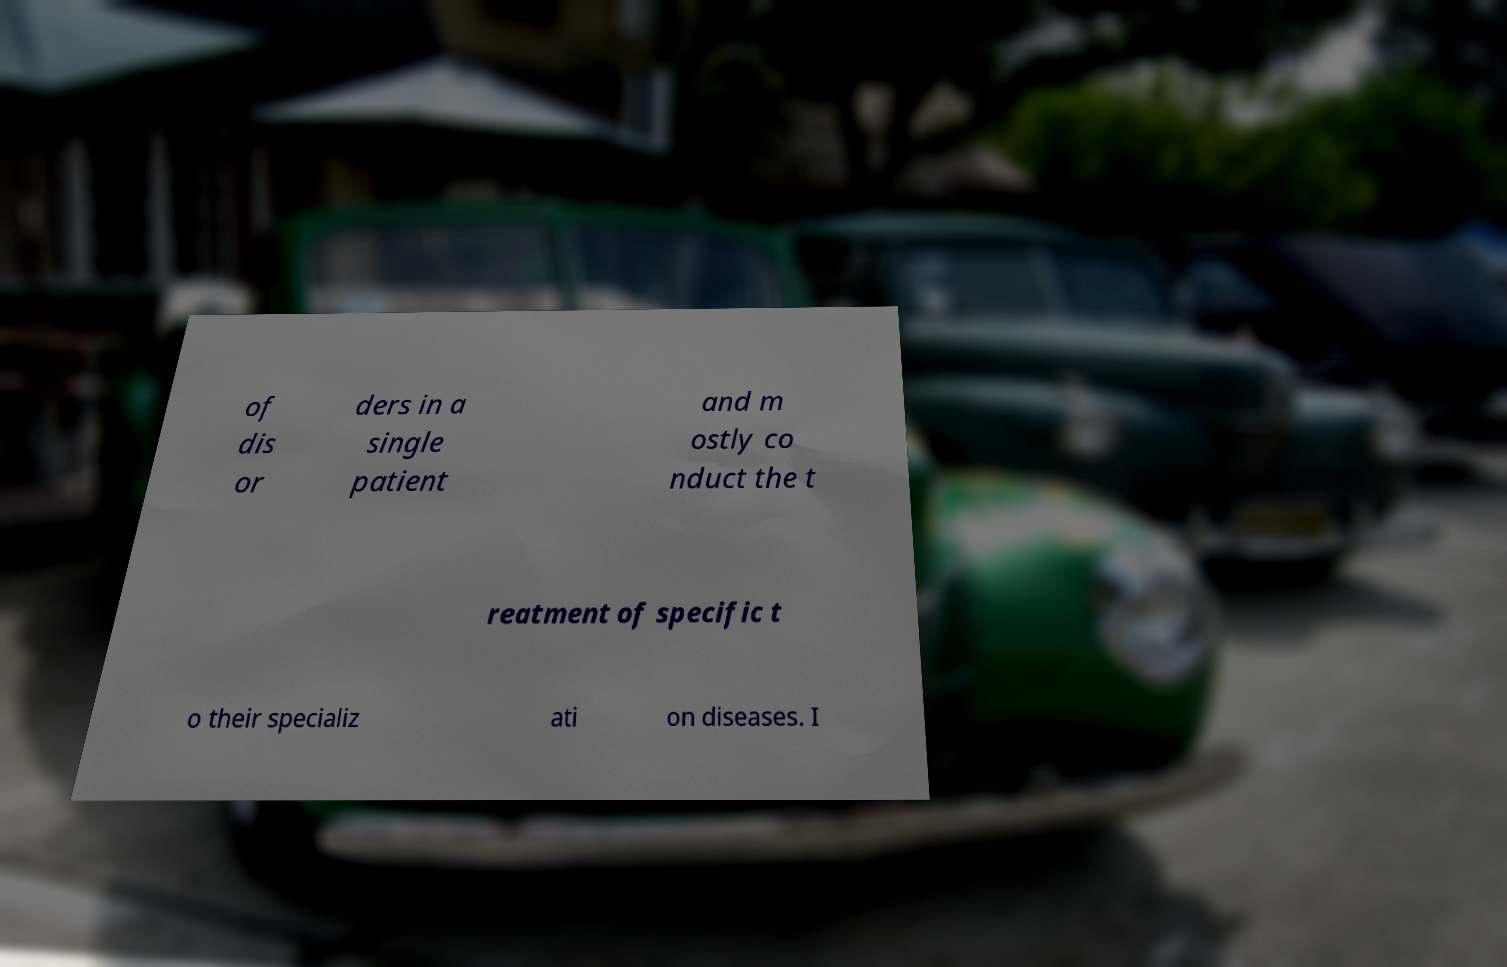For documentation purposes, I need the text within this image transcribed. Could you provide that? of dis or ders in a single patient and m ostly co nduct the t reatment of specific t o their specializ ati on diseases. I 